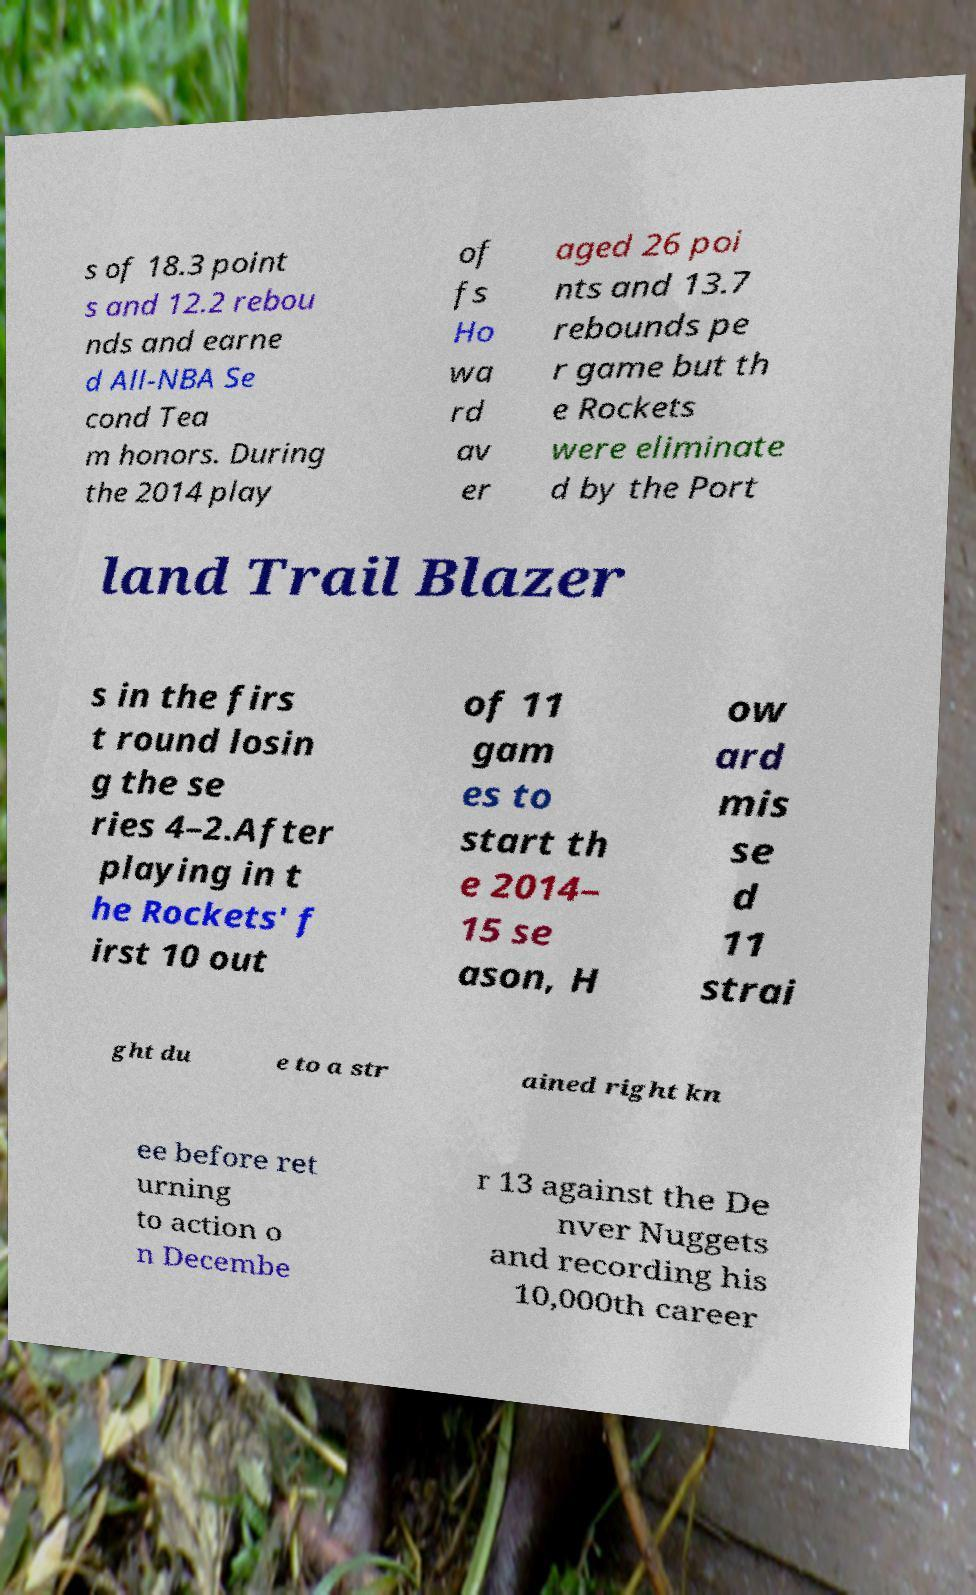Please read and relay the text visible in this image. What does it say? s of 18.3 point s and 12.2 rebou nds and earne d All-NBA Se cond Tea m honors. During the 2014 play of fs Ho wa rd av er aged 26 poi nts and 13.7 rebounds pe r game but th e Rockets were eliminate d by the Port land Trail Blazer s in the firs t round losin g the se ries 4–2.After playing in t he Rockets' f irst 10 out of 11 gam es to start th e 2014– 15 se ason, H ow ard mis se d 11 strai ght du e to a str ained right kn ee before ret urning to action o n Decembe r 13 against the De nver Nuggets and recording his 10,000th career 